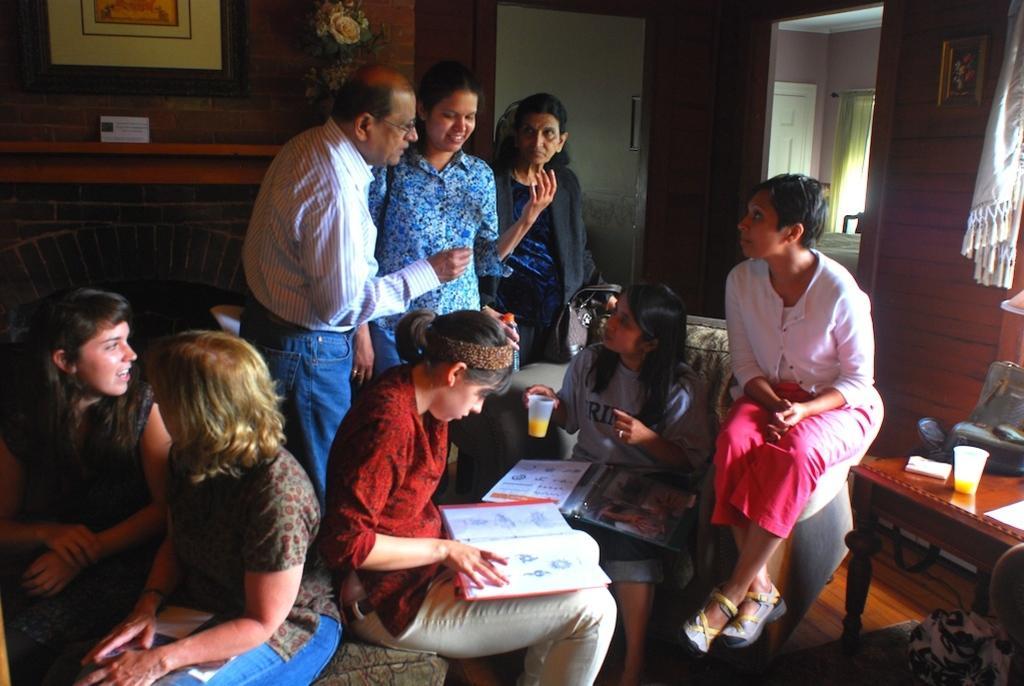Describe this image in one or two sentences. In the picture I can see these people are sitting on the sofa and these people are standing here and these two persons are holding books in their hands. In the background, I can see the fireplace, photo frames on the wall, curtains, table on which we can see few things are kept, we can see doors, flower vase and another room. 